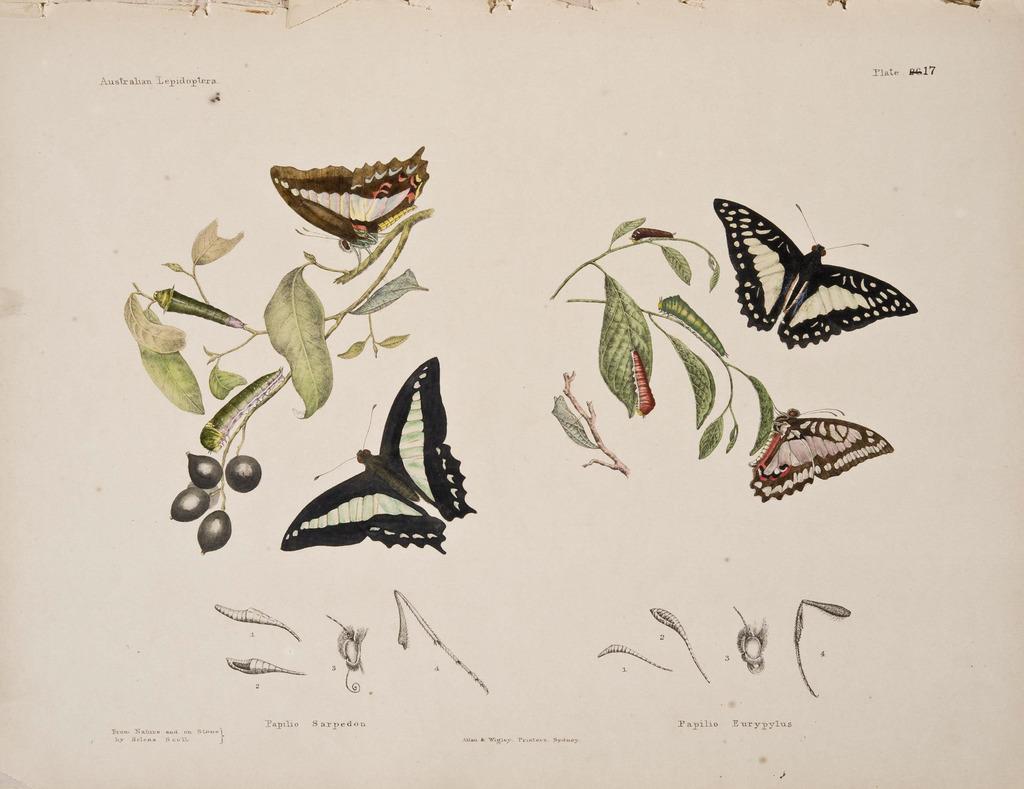Can you describe this image briefly? In this image we can see an image of a paper. In the paper, we can see images of insects. At the bottom we can see the text. 